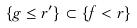<formula> <loc_0><loc_0><loc_500><loc_500>\{ g \leq r ^ { \prime } \} \subset \{ f < r \}</formula> 